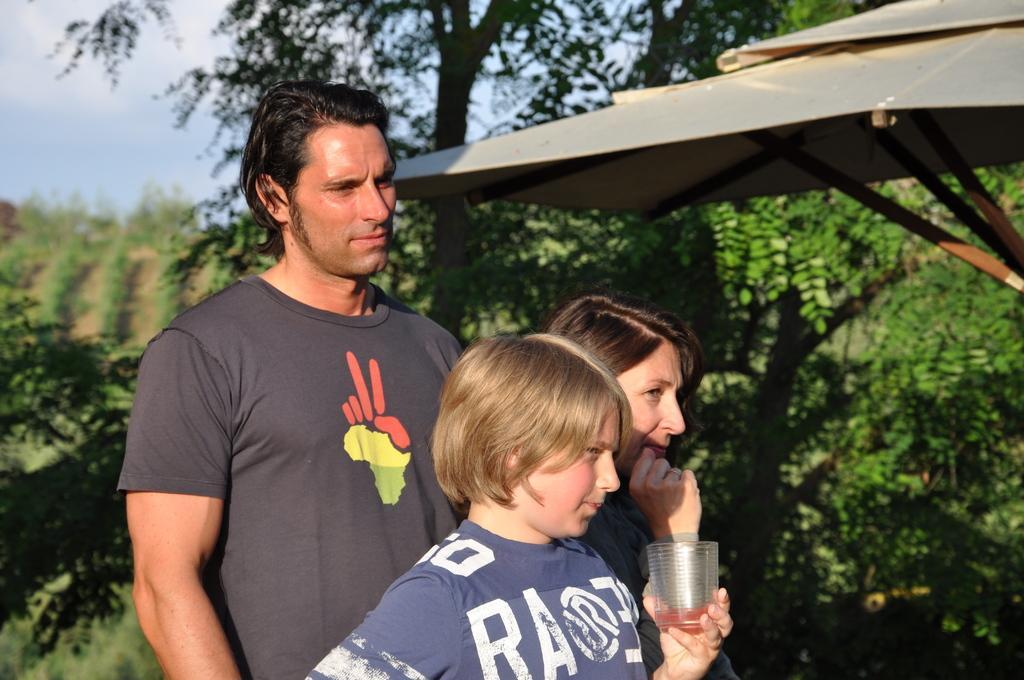How would you summarize this image in a sentence or two? In the picture we can see a man, a woman and a child are standing near the tent and child is holding a glass and behind them, we can see some plants and trees and top of it we can see a part of the sky. 